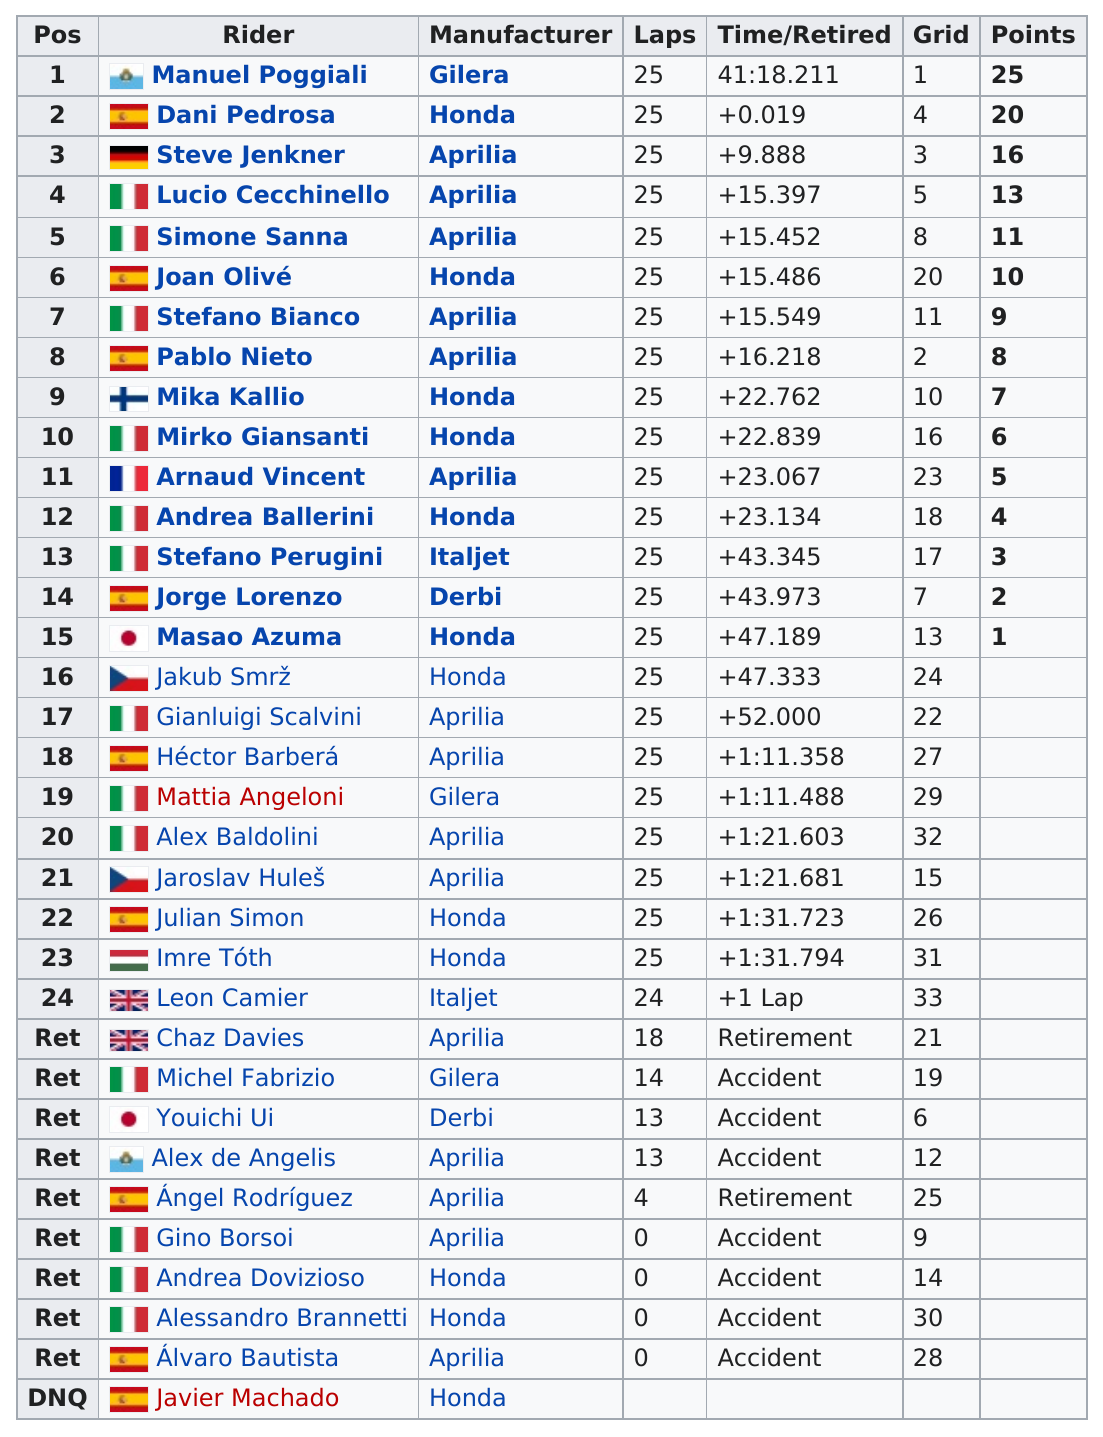Indicate a few pertinent items in this graphic. Out of the total number of riders who participated, how many scored at least 20 points? The total number of vehicles whose manufacturer is Honda is 12. After Joan O. was Stefano Bianco. It is known that 14 riders rode motorcycles from the same manufacturer as Arnaud Vincent. The person who earned the least number of points among those in the top 15 positions is Masao Azuma. 